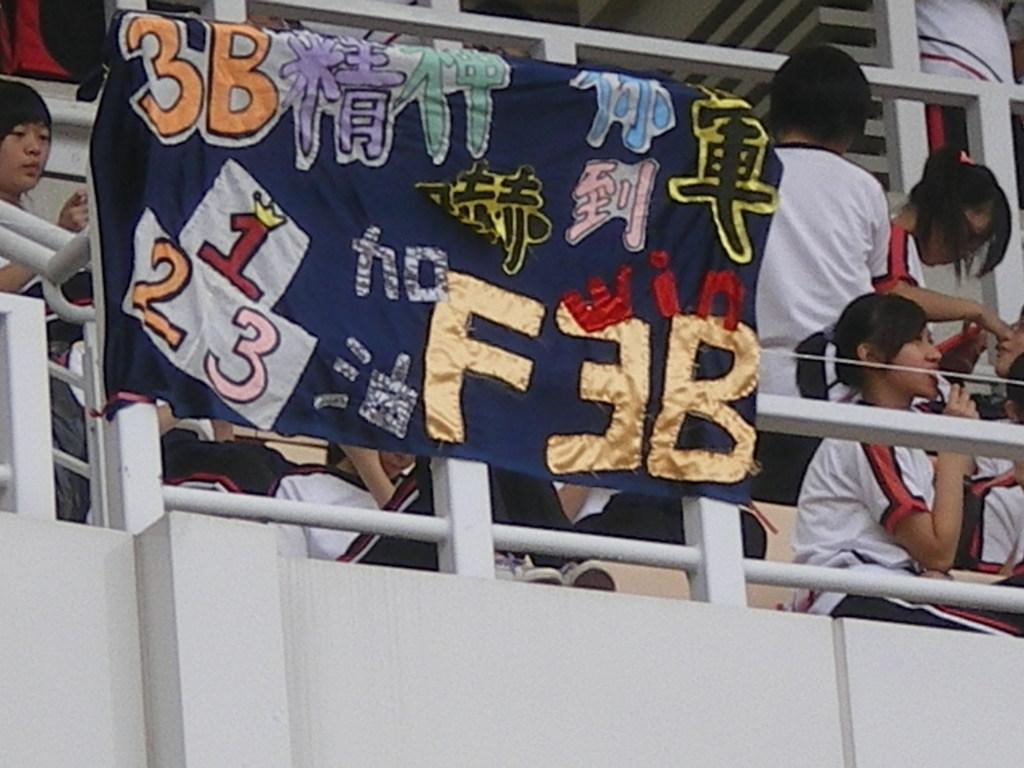How would you summarize this image in a sentence or two? In this image, we can see a banner, rods, wall, a group of people. Few people are sitting and standing. 